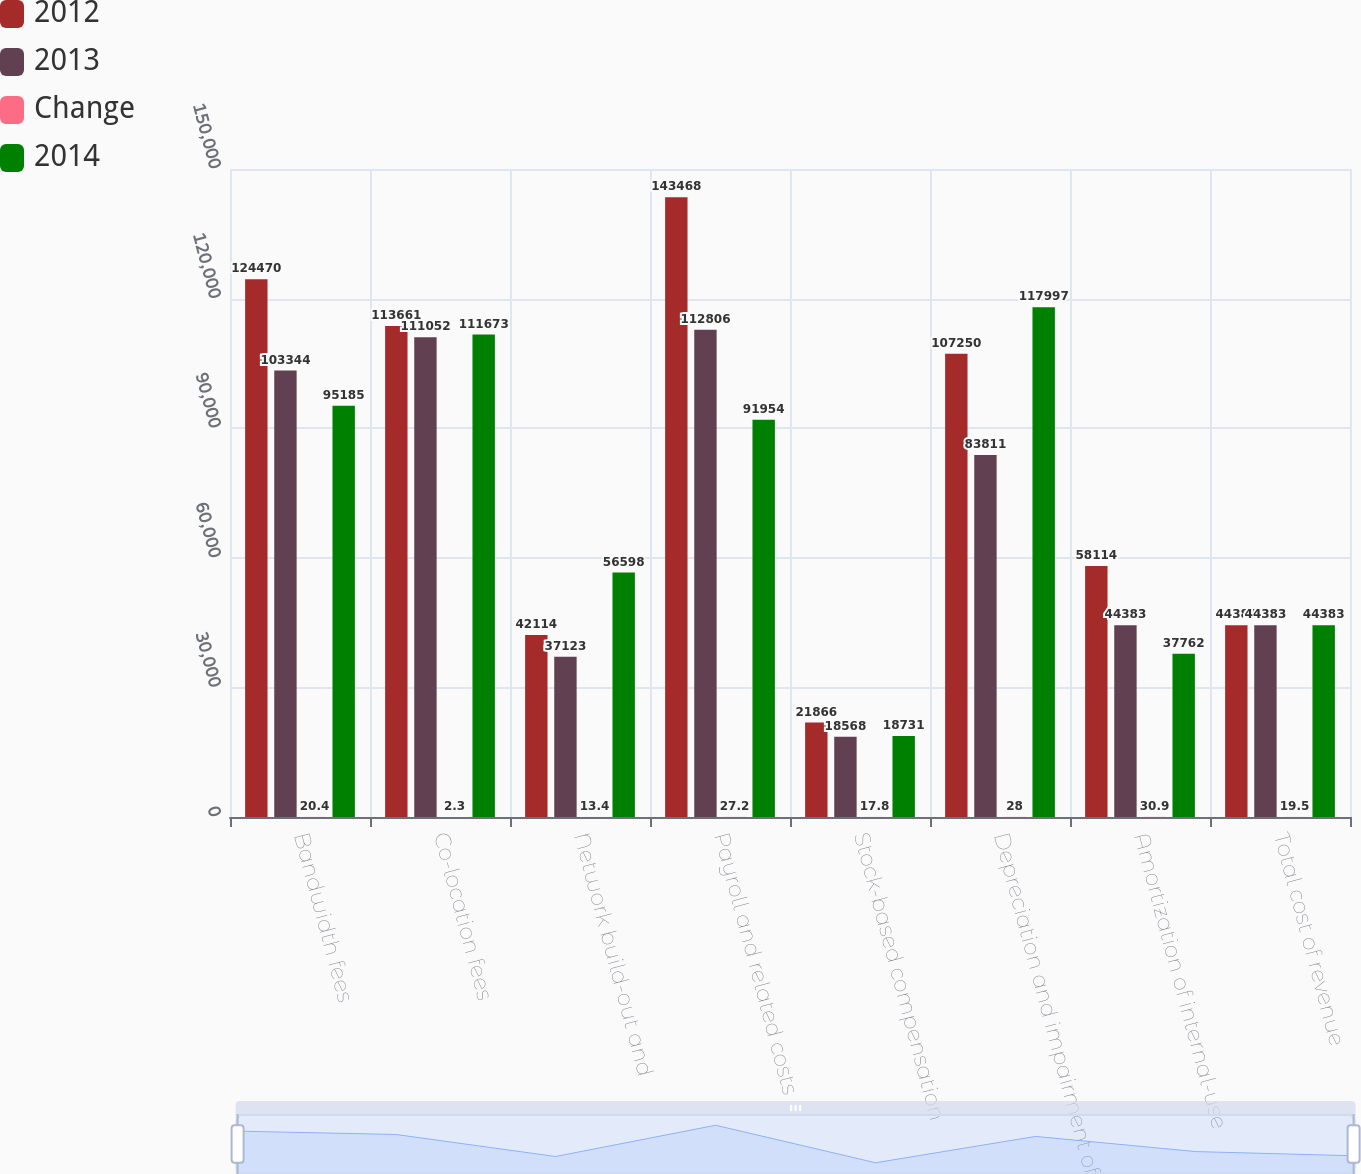Convert chart. <chart><loc_0><loc_0><loc_500><loc_500><stacked_bar_chart><ecel><fcel>Bandwidth fees<fcel>Co-location fees<fcel>Network build-out and<fcel>Payroll and related costs<fcel>Stock-based compensation<fcel>Depreciation and impairment of<fcel>Amortization of internal-use<fcel>Total cost of revenue<nl><fcel>2012<fcel>124470<fcel>113661<fcel>42114<fcel>143468<fcel>21866<fcel>107250<fcel>58114<fcel>44383<nl><fcel>2013<fcel>103344<fcel>111052<fcel>37123<fcel>112806<fcel>18568<fcel>83811<fcel>44383<fcel>44383<nl><fcel>Change<fcel>20.4<fcel>2.3<fcel>13.4<fcel>27.2<fcel>17.8<fcel>28<fcel>30.9<fcel>19.5<nl><fcel>2014<fcel>95185<fcel>111673<fcel>56598<fcel>91954<fcel>18731<fcel>117997<fcel>37762<fcel>44383<nl></chart> 